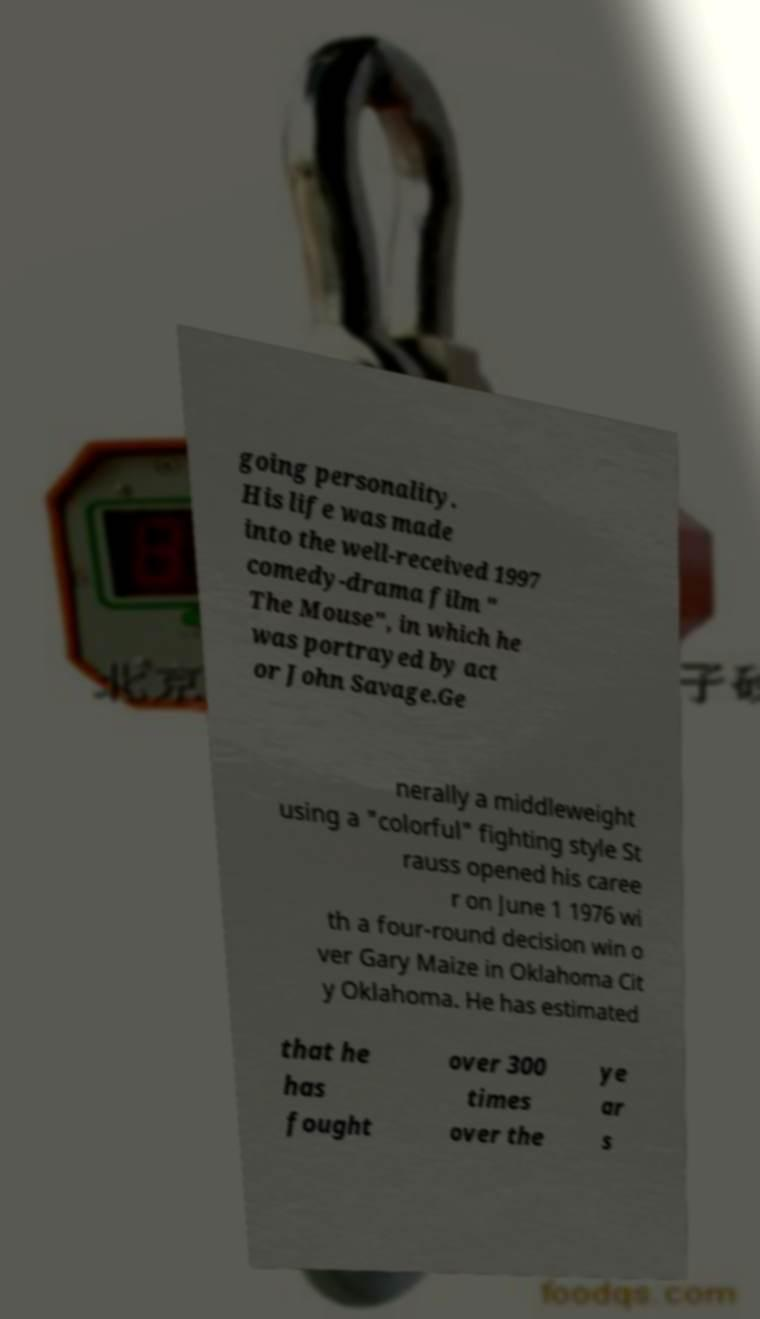What messages or text are displayed in this image? I need them in a readable, typed format. going personality. His life was made into the well-received 1997 comedy-drama film " The Mouse", in which he was portrayed by act or John Savage.Ge nerally a middleweight using a "colorful" fighting style St rauss opened his caree r on June 1 1976 wi th a four-round decision win o ver Gary Maize in Oklahoma Cit y Oklahoma. He has estimated that he has fought over 300 times over the ye ar s 